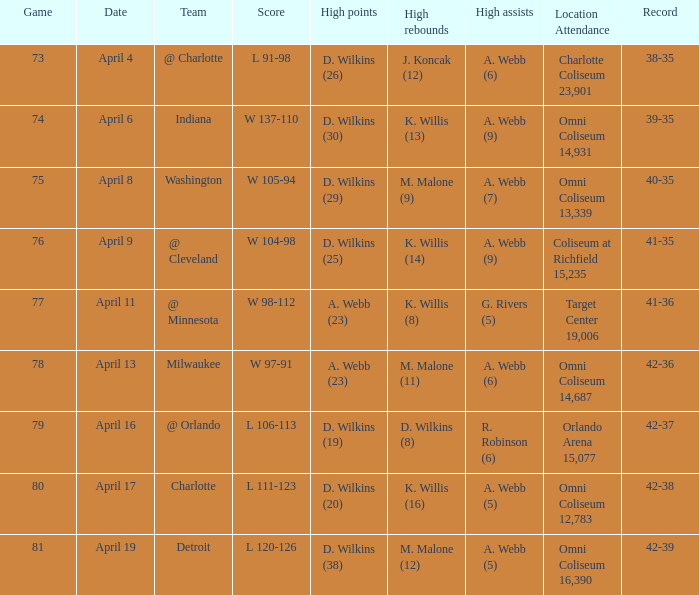When did g. rivers (5) register the top assists in a single match? April 11. 